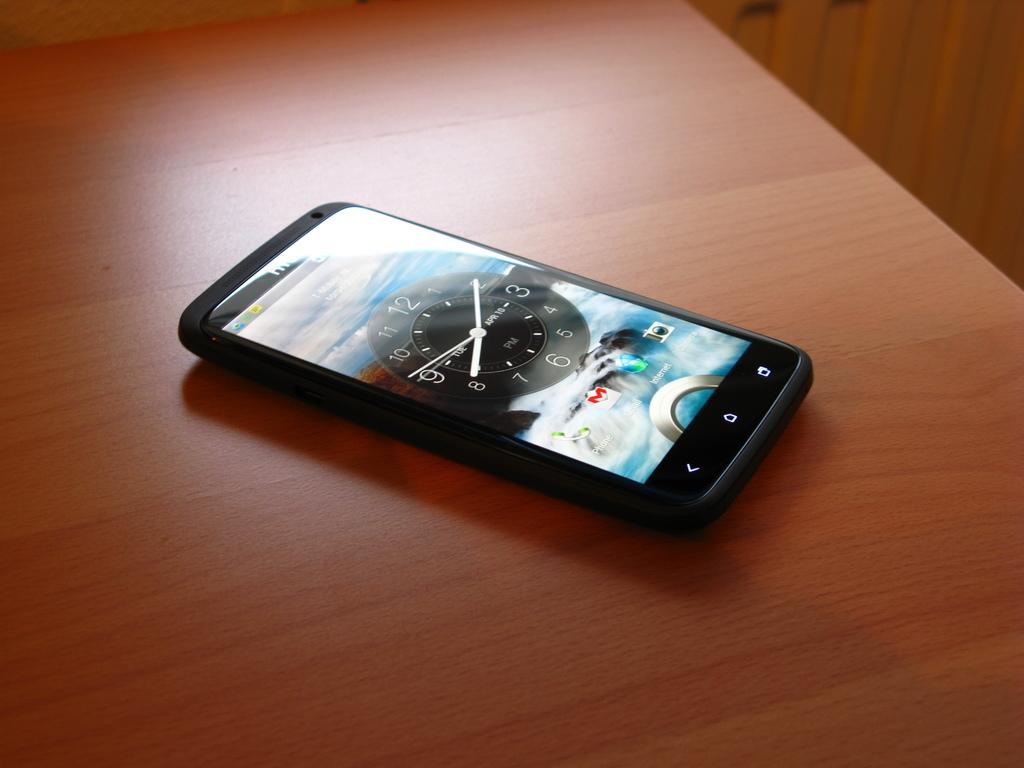Provide a one-sentence caption for the provided image. A smart phone sits on the table and its lock screen reads 8:10. 